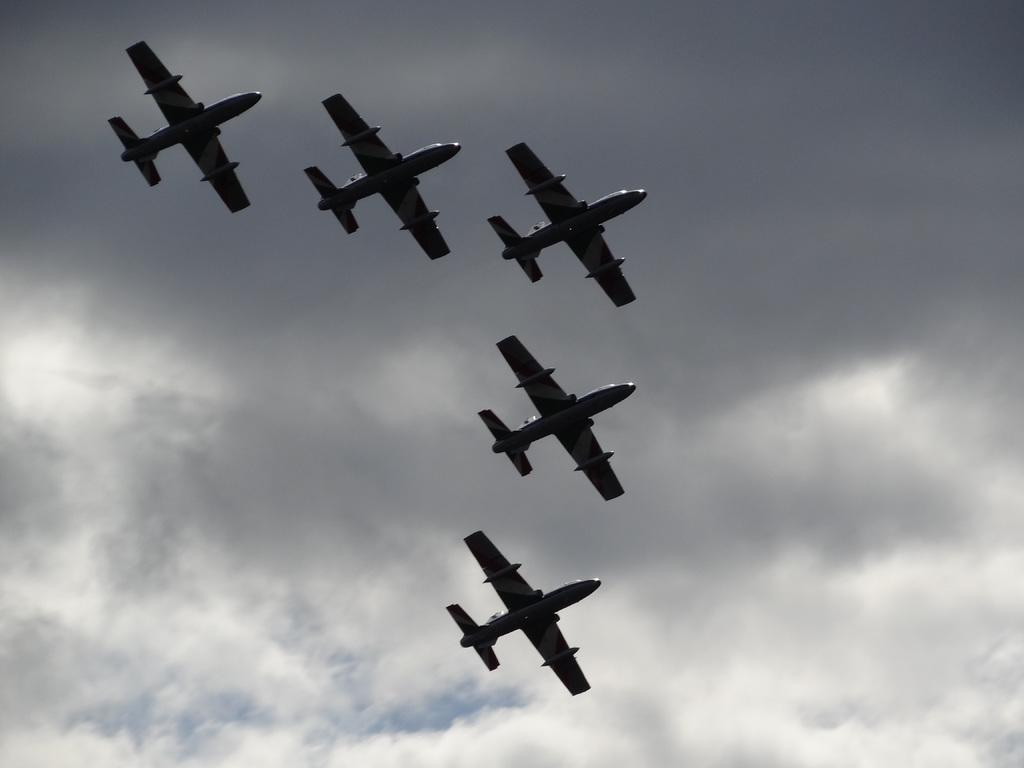What is happening in the image? There are airplanes flying in the image. What can be seen in the background of the image? The sky is visible in the background of the image. What is the condition of the sky in the image? The sky is cloudy in the image. What type of wax is being used to create the calendar in the image? There is no calendar or wax present in the image. How is the bait being used in the image? There is no bait present in the image. 